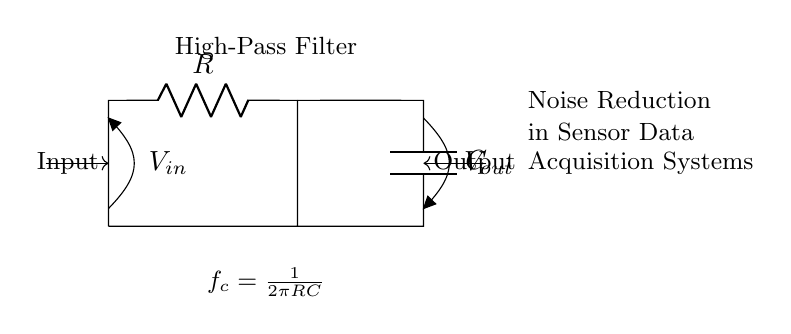What is the type of filter shown? The circuit diagram depicts a high-pass filter, which allows high frequencies to pass while attenuating lower frequencies. This is indicated by the arrangement of the resistor and capacitor.
Answer: High-pass filter What component is used to block low-frequency signals? In a high-pass filter, the capacitor is the component that blocks low-frequency signals while allowing high frequencies to pass through. This is evident from its position in the circuit diagram.
Answer: Capacitor What is represented by V_in in the circuit? V_in represents the input voltage of the filter circuit. It is the voltage that is applied across the entire circuit before filtering occurs, shown on the left side of the diagram.
Answer: Input voltage What is the cutoff frequency formula shown in the diagram? The cutoff frequency formula is indicated in the description of the circuit and is given by f_c equals one over two pi R C. This formula helps determine the frequency at which the filter begins to significantly attenuate lower frequencies.
Answer: f_c = 1/(2πRC) What is the output voltage denoted as in the circuit? The output voltage is denoted as V_out in the circuit diagram. It is the voltage that appears across the capacitor after the filtering process, shown on the right side of the circuit.
Answer: Output voltage Which component determines the filtering characteristics of the circuit? The resistor R and capacitor C together determine the filtering characteristics, as their values set the cutoff frequency of the high-pass filter. This can be derived from their roles in the circuit configuration and the cutoff frequency formula.
Answer: R and C What happens to high-frequency signals in this circuit? High-frequency signals are allowed to pass through the high-pass filter, as indicated by the circuit design, while lower frequency signals are attenuated or reduced. This is a fundamental behavior of high-pass filter circuits.
Answer: Allowed to pass 